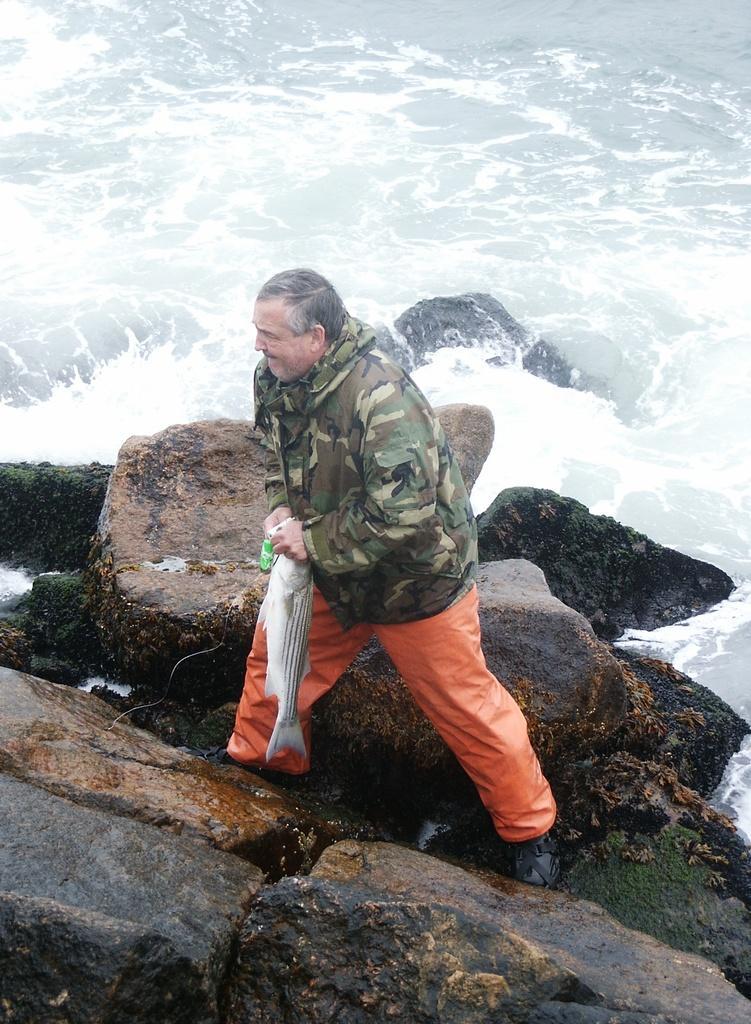In one or two sentences, can you explain what this image depicts? In the foreground of this picture, there is a man on the rock, holding a fish in his hand. In the background, there are rocks and the water. 